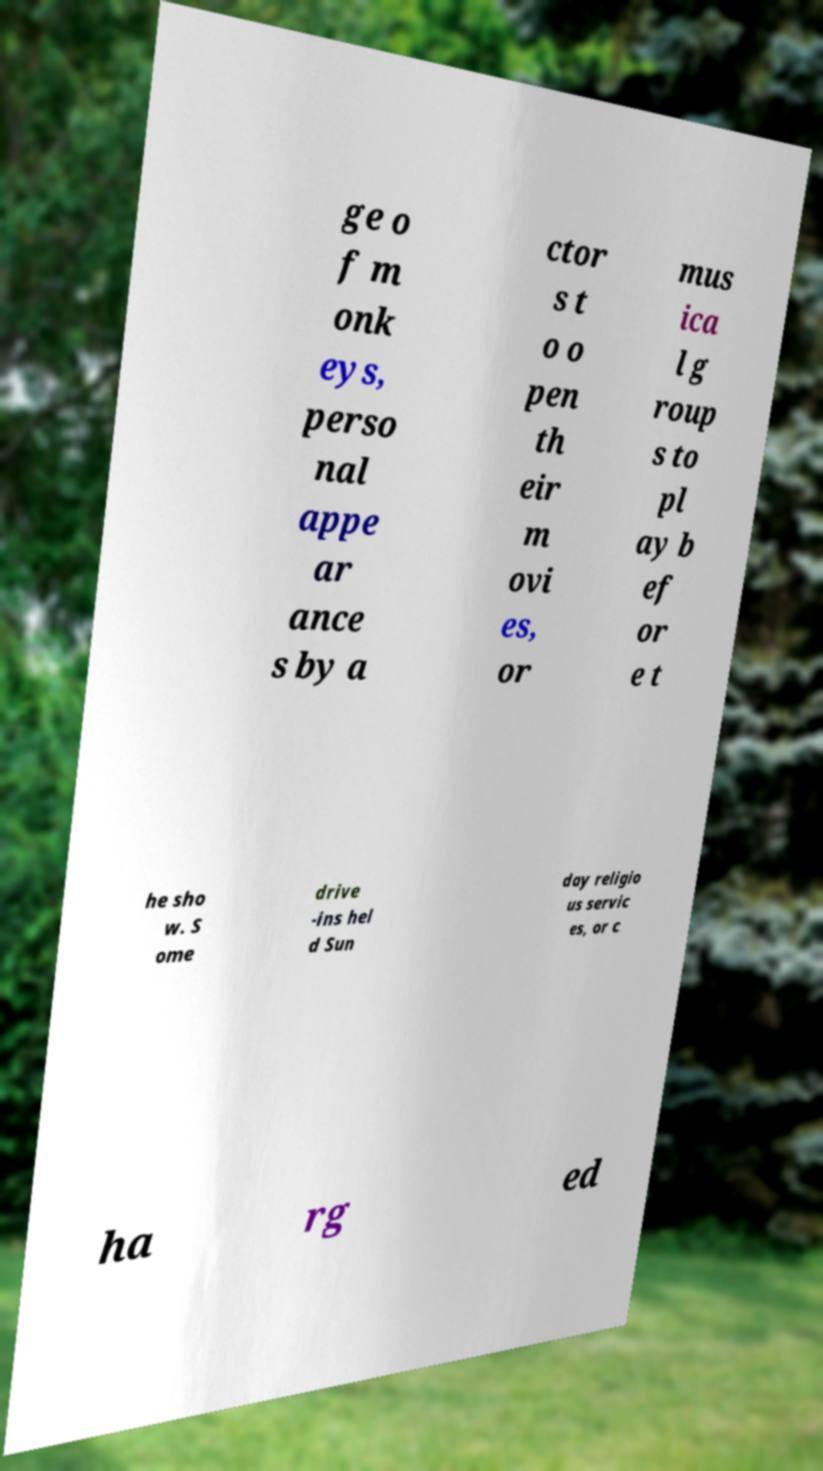Please read and relay the text visible in this image. What does it say? ge o f m onk eys, perso nal appe ar ance s by a ctor s t o o pen th eir m ovi es, or mus ica l g roup s to pl ay b ef or e t he sho w. S ome drive -ins hel d Sun day religio us servic es, or c ha rg ed 